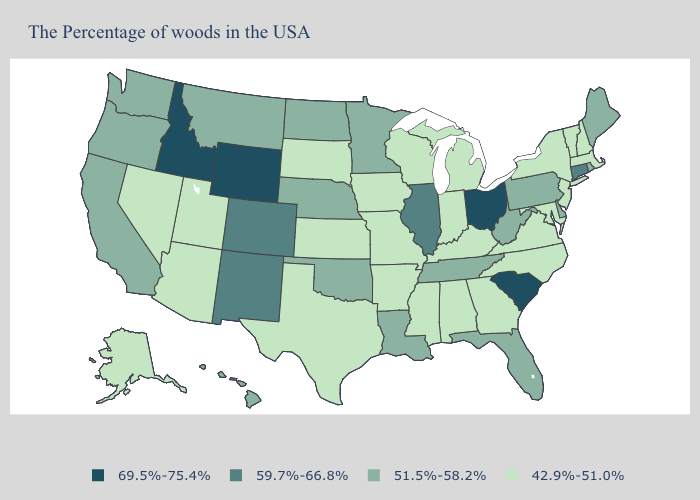Which states have the lowest value in the West?
Give a very brief answer. Utah, Arizona, Nevada, Alaska. Name the states that have a value in the range 59.7%-66.8%?
Keep it brief. Connecticut, Illinois, Colorado, New Mexico. Name the states that have a value in the range 42.9%-51.0%?
Short answer required. Massachusetts, New Hampshire, Vermont, New York, New Jersey, Maryland, Virginia, North Carolina, Georgia, Michigan, Kentucky, Indiana, Alabama, Wisconsin, Mississippi, Missouri, Arkansas, Iowa, Kansas, Texas, South Dakota, Utah, Arizona, Nevada, Alaska. What is the value of Vermont?
Keep it brief. 42.9%-51.0%. Name the states that have a value in the range 69.5%-75.4%?
Give a very brief answer. South Carolina, Ohio, Wyoming, Idaho. What is the value of Texas?
Answer briefly. 42.9%-51.0%. What is the highest value in the MidWest ?
Keep it brief. 69.5%-75.4%. What is the value of Texas?
Answer briefly. 42.9%-51.0%. Which states have the highest value in the USA?
Keep it brief. South Carolina, Ohio, Wyoming, Idaho. What is the highest value in the South ?
Write a very short answer. 69.5%-75.4%. Name the states that have a value in the range 69.5%-75.4%?
Keep it brief. South Carolina, Ohio, Wyoming, Idaho. Which states have the lowest value in the West?
Keep it brief. Utah, Arizona, Nevada, Alaska. Name the states that have a value in the range 69.5%-75.4%?
Give a very brief answer. South Carolina, Ohio, Wyoming, Idaho. Which states have the highest value in the USA?
Quick response, please. South Carolina, Ohio, Wyoming, Idaho. How many symbols are there in the legend?
Concise answer only. 4. 